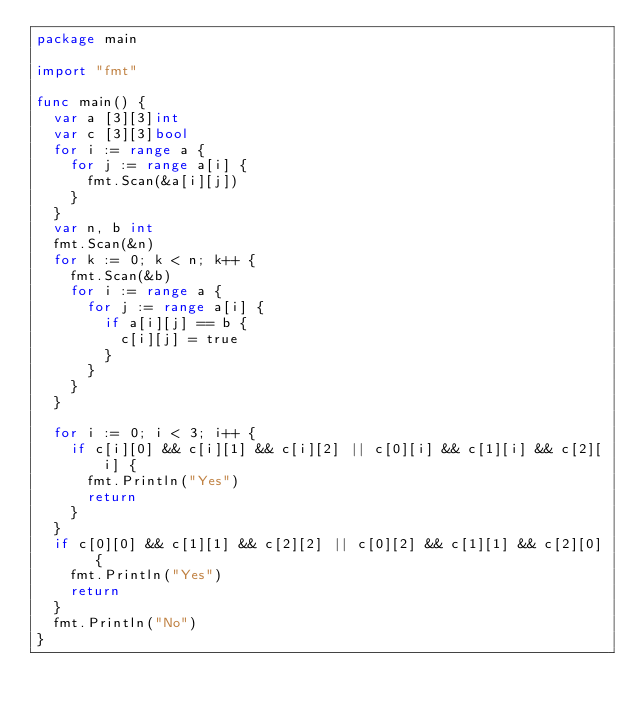Convert code to text. <code><loc_0><loc_0><loc_500><loc_500><_Go_>package main

import "fmt"

func main() {
	var a [3][3]int
	var c [3][3]bool
	for i := range a {
		for j := range a[i] {
			fmt.Scan(&a[i][j])
		}
	}
	var n, b int
	fmt.Scan(&n)
	for k := 0; k < n; k++ {
		fmt.Scan(&b)
		for i := range a {
			for j := range a[i] {
				if a[i][j] == b {
					c[i][j] = true
				}
			}
		}
	}

	for i := 0; i < 3; i++ {
		if c[i][0] && c[i][1] && c[i][2] || c[0][i] && c[1][i] && c[2][i] {
			fmt.Println("Yes")
			return
		}
	}
	if c[0][0] && c[1][1] && c[2][2] || c[0][2] && c[1][1] && c[2][0] {
		fmt.Println("Yes")
		return
	}
	fmt.Println("No")
}
</code> 